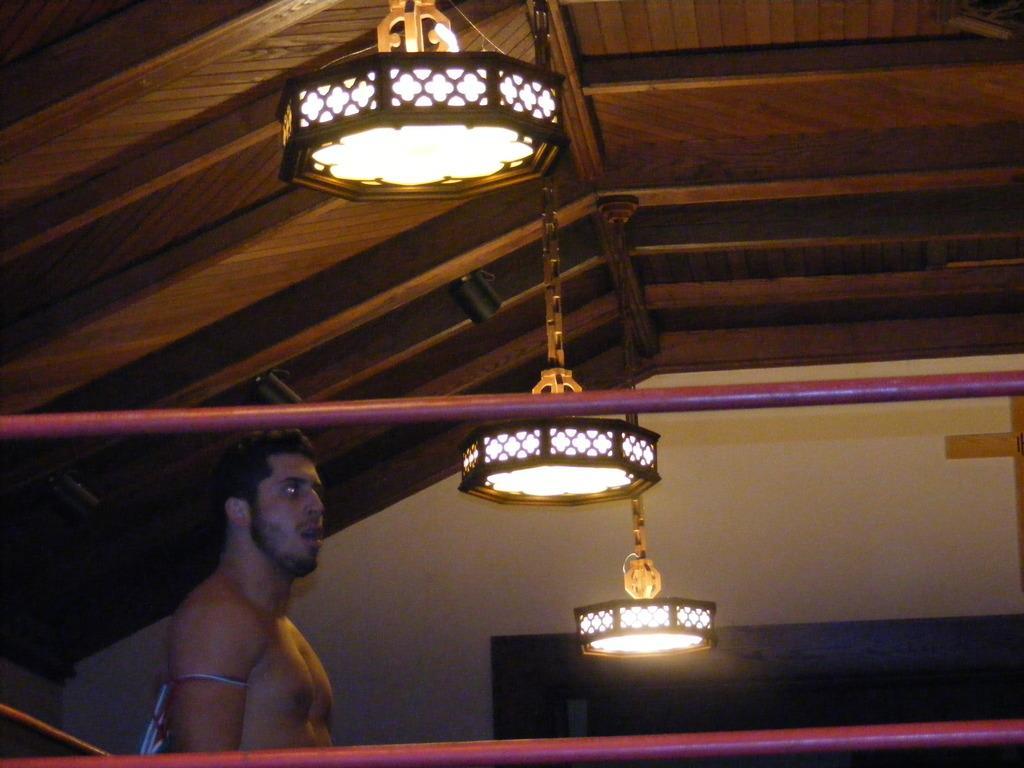Can you describe this image briefly? This picture is clicked inside the house. On the left we can see a person seems to be standing and we can see the metal rods. At the top there is a roof and we can see the lamps hanging on the roof. In the background we can see the wall and some other objects. 